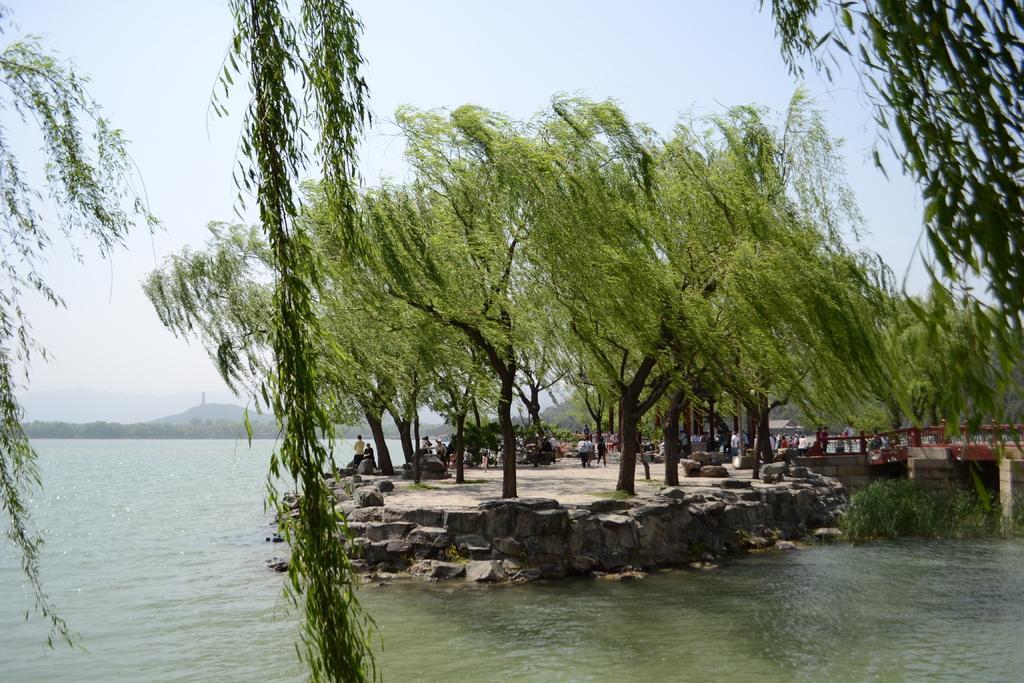Describe this image in one or two sentences. In this image we can see a few people, trees, plants, rocks, water and a bridge, in the background we can see some mountains and the sky. 